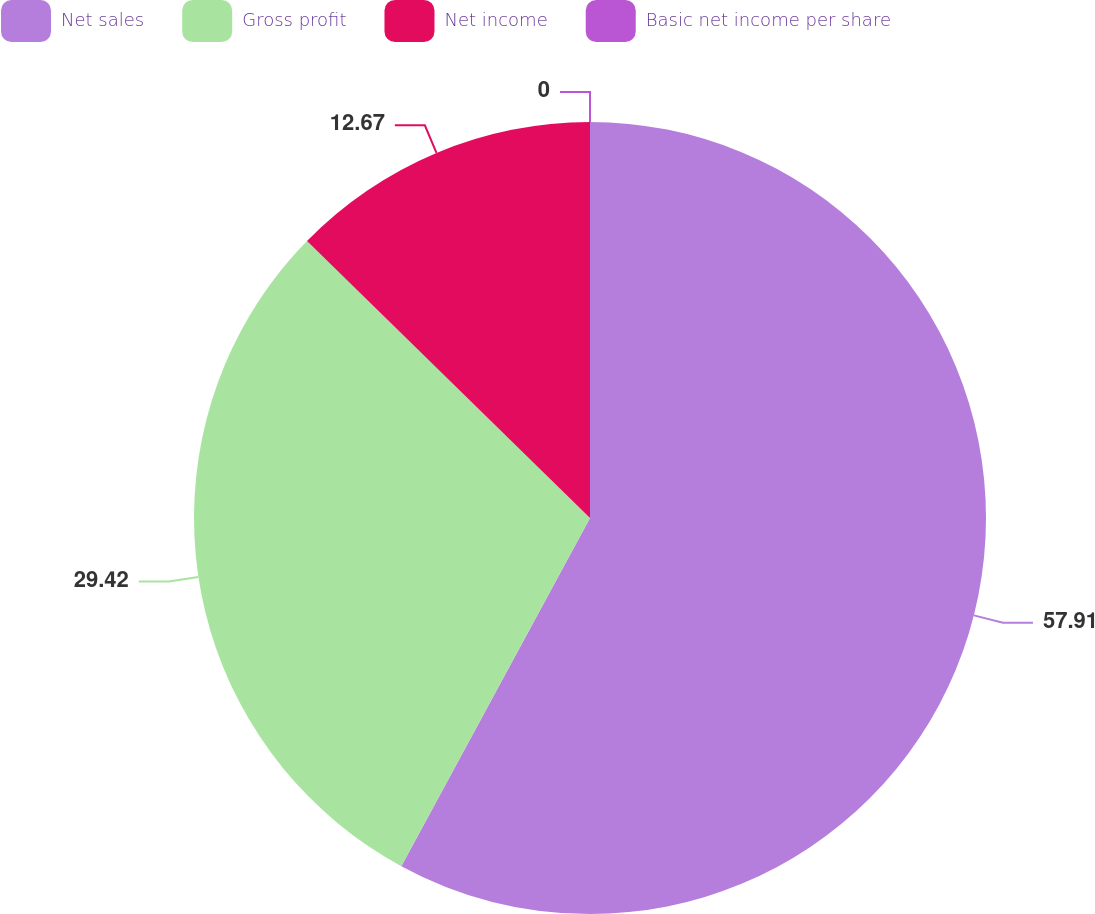<chart> <loc_0><loc_0><loc_500><loc_500><pie_chart><fcel>Net sales<fcel>Gross profit<fcel>Net income<fcel>Basic net income per share<nl><fcel>57.9%<fcel>29.42%<fcel>12.67%<fcel>0.0%<nl></chart> 